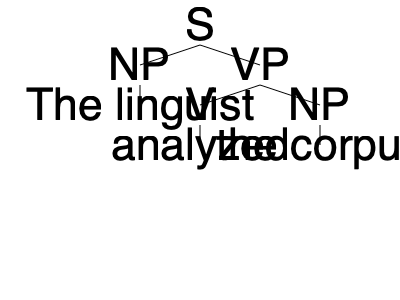Examine the syntactic tree diagram above. What is the constituent structure of the verb phrase (VP) in this sentence? To determine the constituent structure of the verb phrase (VP) in this sentence, we need to follow these steps:

1. Identify the VP node in the tree diagram.
2. Examine the branches immediately below the VP node.
3. Determine the syntactic categories of these branches.

Step 1: The VP node is clearly visible in the second level of the tree, on the right side.

Step 2: Below the VP node, we can see two branches:
   - One branch leads to a V (verb) node
   - The other branch leads to an NP (noun phrase) node

Step 3: The syntactic categories are:
   - V: This represents the main verb of the sentence, which is "analyzed"
   - NP: This represents the object of the verb, which is "the corpus"

Therefore, the constituent structure of the VP is a verb (V) followed by a noun phrase (NP). In linguistic notation, this is often written as VP → V NP.

This structure represents a transitive verb phrase, where the verb "analyzed" takes a direct object "the corpus".
Answer: V NP 